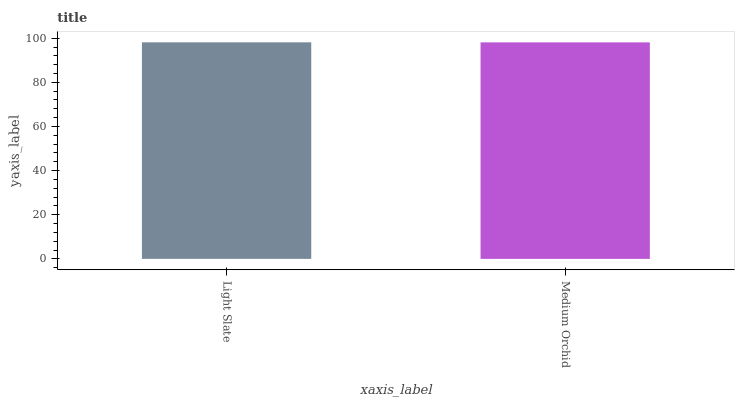Is Medium Orchid the minimum?
Answer yes or no. Yes. Is Light Slate the maximum?
Answer yes or no. Yes. Is Medium Orchid the maximum?
Answer yes or no. No. Is Light Slate greater than Medium Orchid?
Answer yes or no. Yes. Is Medium Orchid less than Light Slate?
Answer yes or no. Yes. Is Medium Orchid greater than Light Slate?
Answer yes or no. No. Is Light Slate less than Medium Orchid?
Answer yes or no. No. Is Light Slate the high median?
Answer yes or no. Yes. Is Medium Orchid the low median?
Answer yes or no. Yes. Is Medium Orchid the high median?
Answer yes or no. No. Is Light Slate the low median?
Answer yes or no. No. 